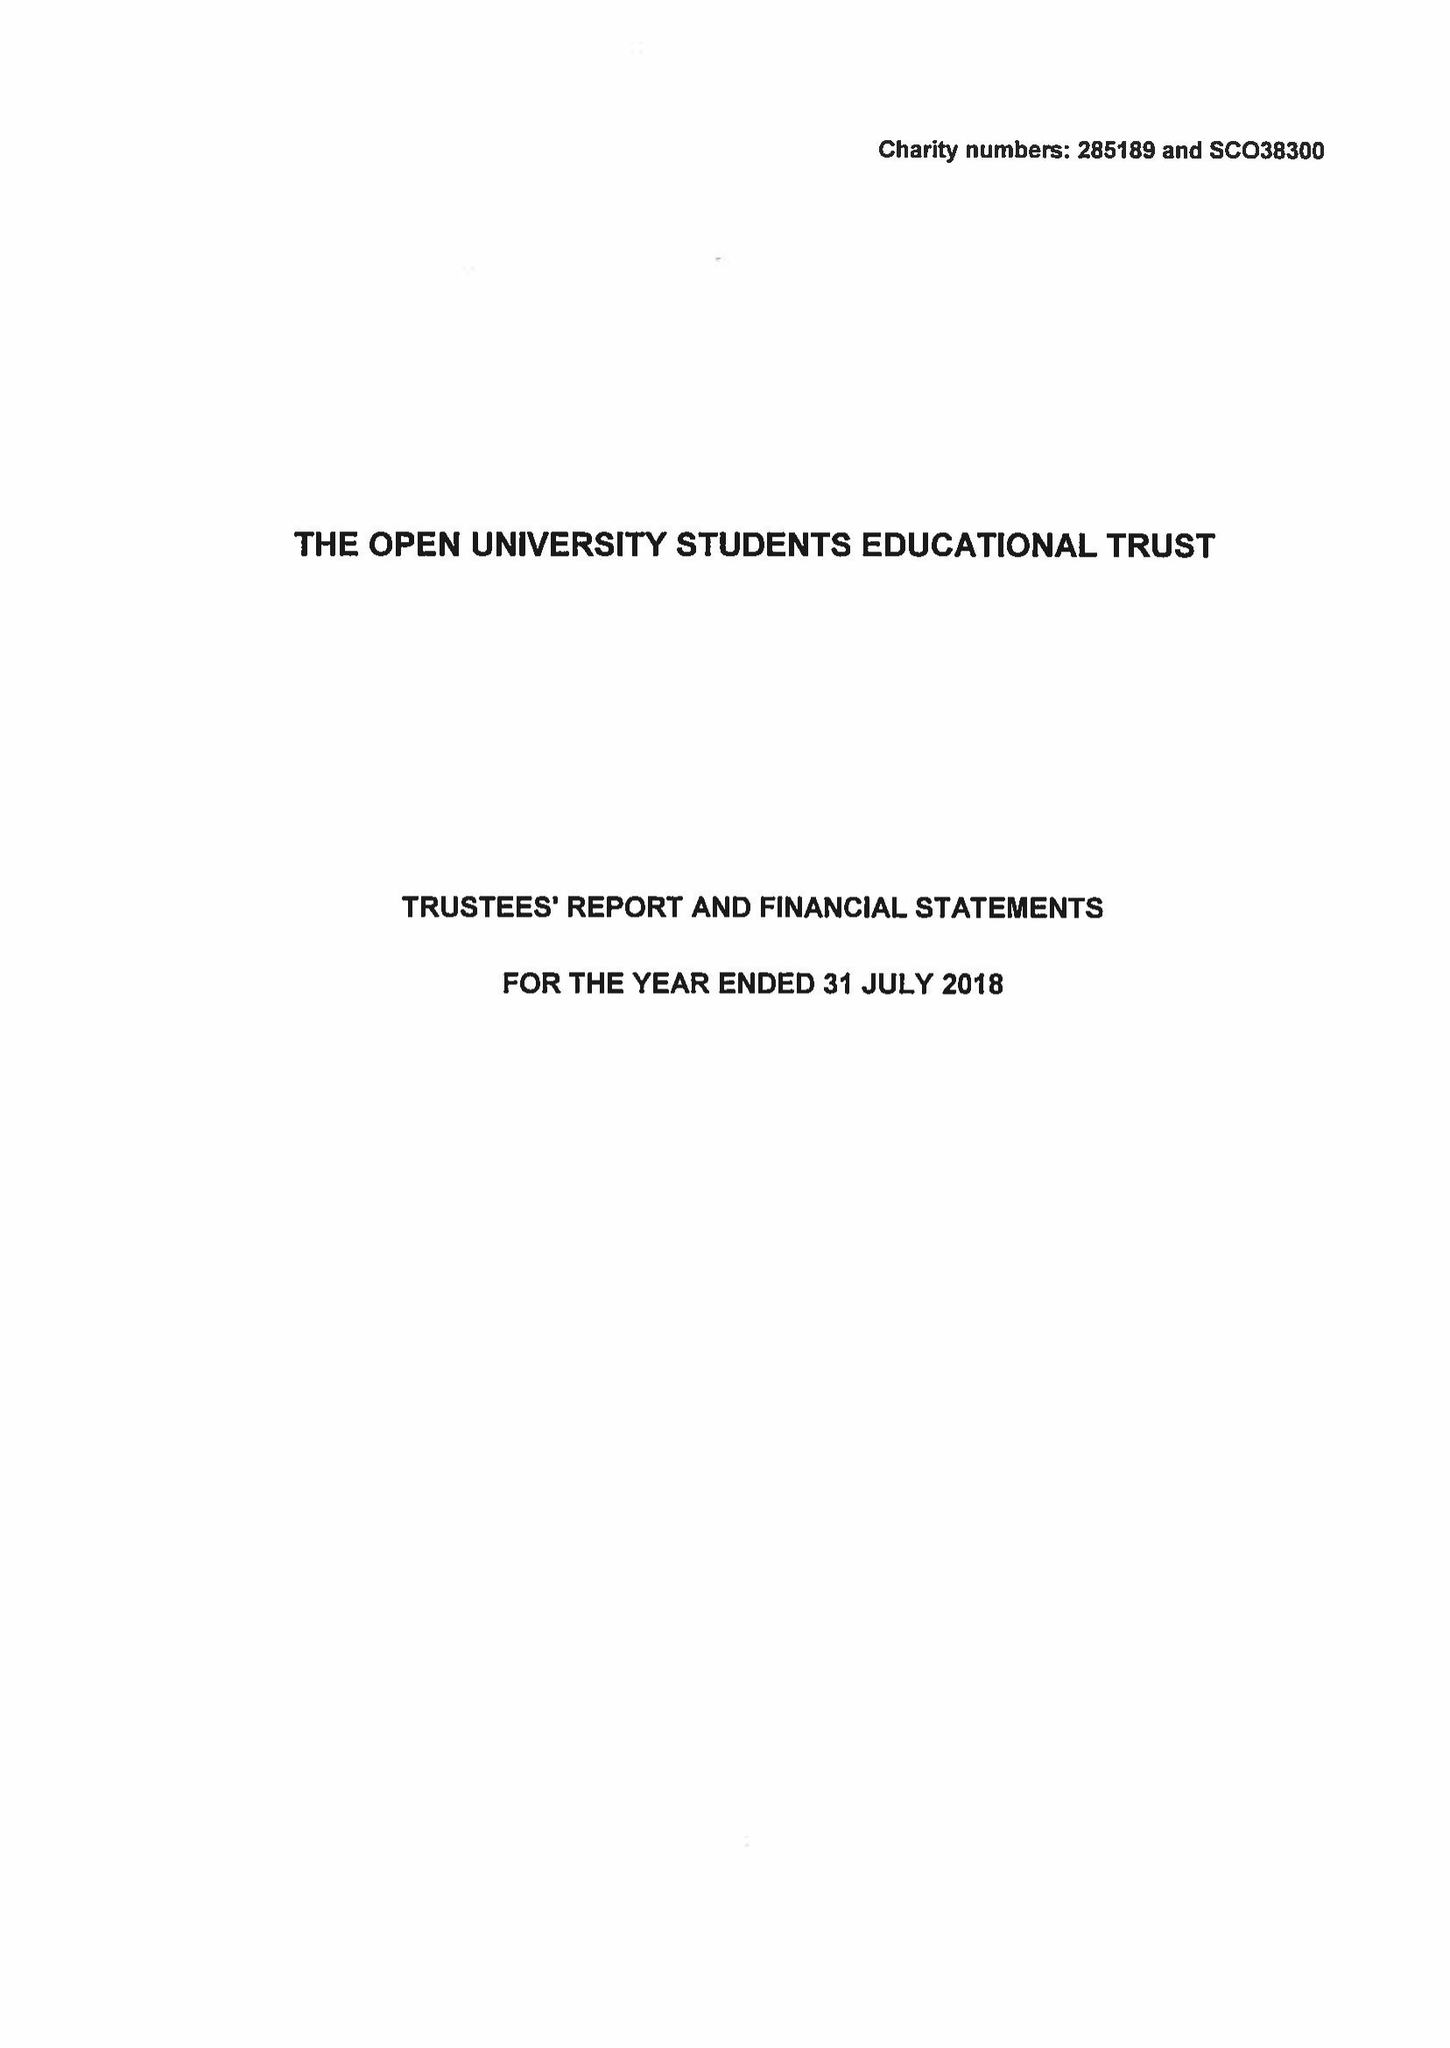What is the value for the address__postcode?
Answer the question using a single word or phrase. MK7 6BE 